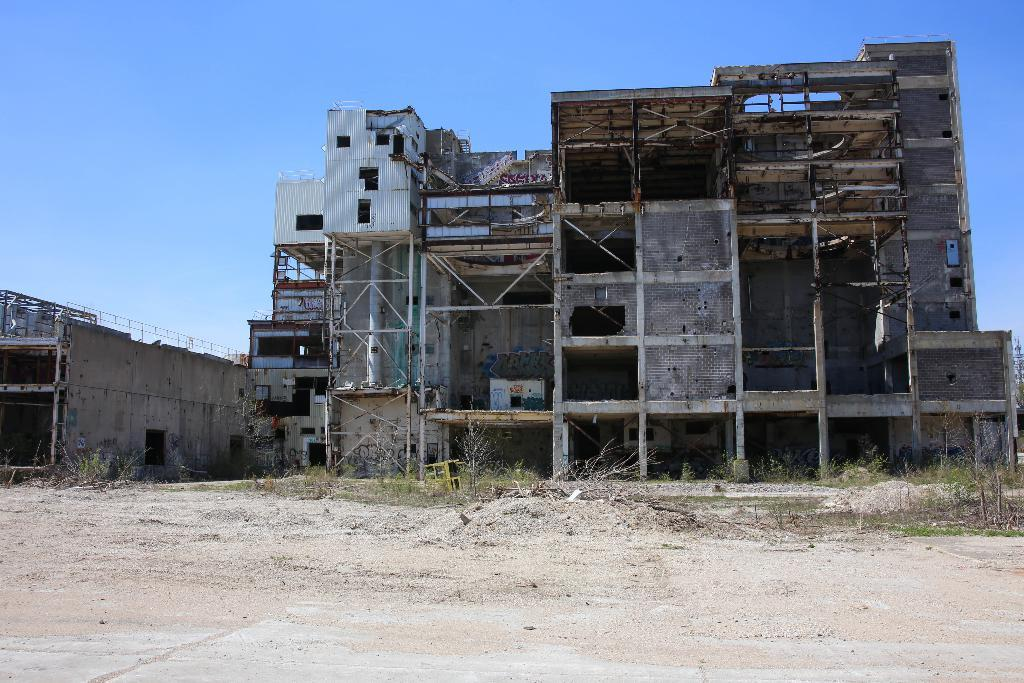What type of terrain is visible in the image? There is a land visible in the image. What structures can be seen in the background of the image? There is an old building in the background of the image. What type of vegetation is present in the background of the image? There are plants in the background of the image. What is visible in the sky in the image? The sky is visible in the background of the image. Is there a volcano erupting in the image? No, there is no volcano present in the image. Can you see any beggars on the land in the image? There is no mention of a beggar in the image, and no such figure is visible. 